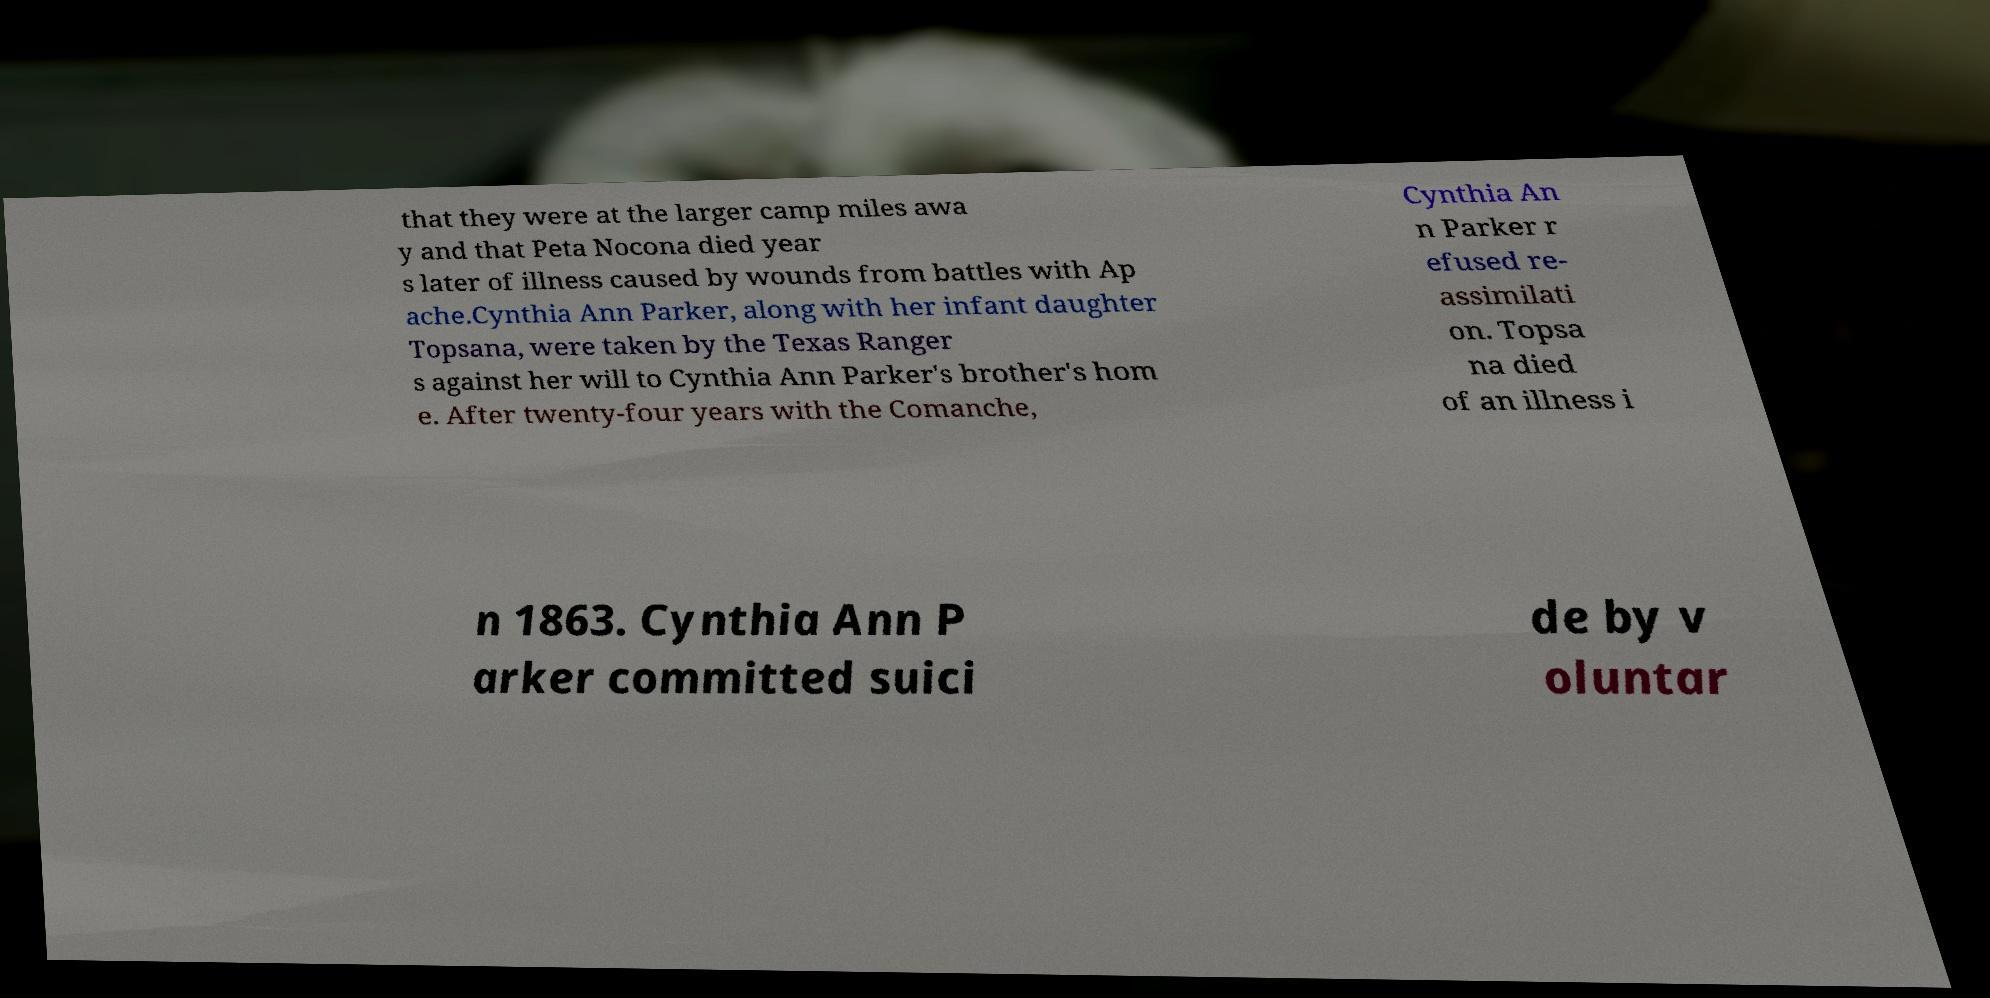Can you accurately transcribe the text from the provided image for me? that they were at the larger camp miles awa y and that Peta Nocona died year s later of illness caused by wounds from battles with Ap ache.Cynthia Ann Parker, along with her infant daughter Topsana, were taken by the Texas Ranger s against her will to Cynthia Ann Parker's brother's hom e. After twenty-four years with the Comanche, Cynthia An n Parker r efused re- assimilati on. Topsa na died of an illness i n 1863. Cynthia Ann P arker committed suici de by v oluntar 